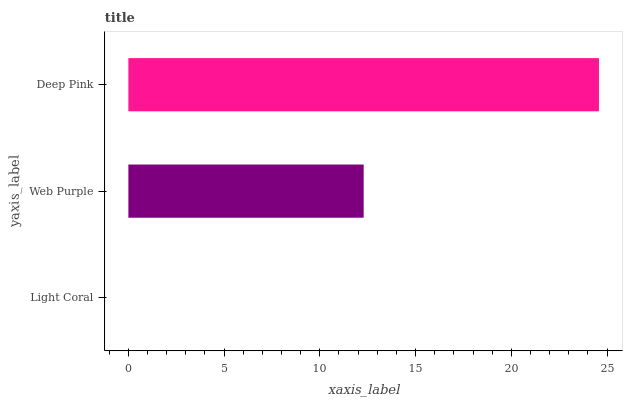Is Light Coral the minimum?
Answer yes or no. Yes. Is Deep Pink the maximum?
Answer yes or no. Yes. Is Web Purple the minimum?
Answer yes or no. No. Is Web Purple the maximum?
Answer yes or no. No. Is Web Purple greater than Light Coral?
Answer yes or no. Yes. Is Light Coral less than Web Purple?
Answer yes or no. Yes. Is Light Coral greater than Web Purple?
Answer yes or no. No. Is Web Purple less than Light Coral?
Answer yes or no. No. Is Web Purple the high median?
Answer yes or no. Yes. Is Web Purple the low median?
Answer yes or no. Yes. Is Deep Pink the high median?
Answer yes or no. No. Is Deep Pink the low median?
Answer yes or no. No. 